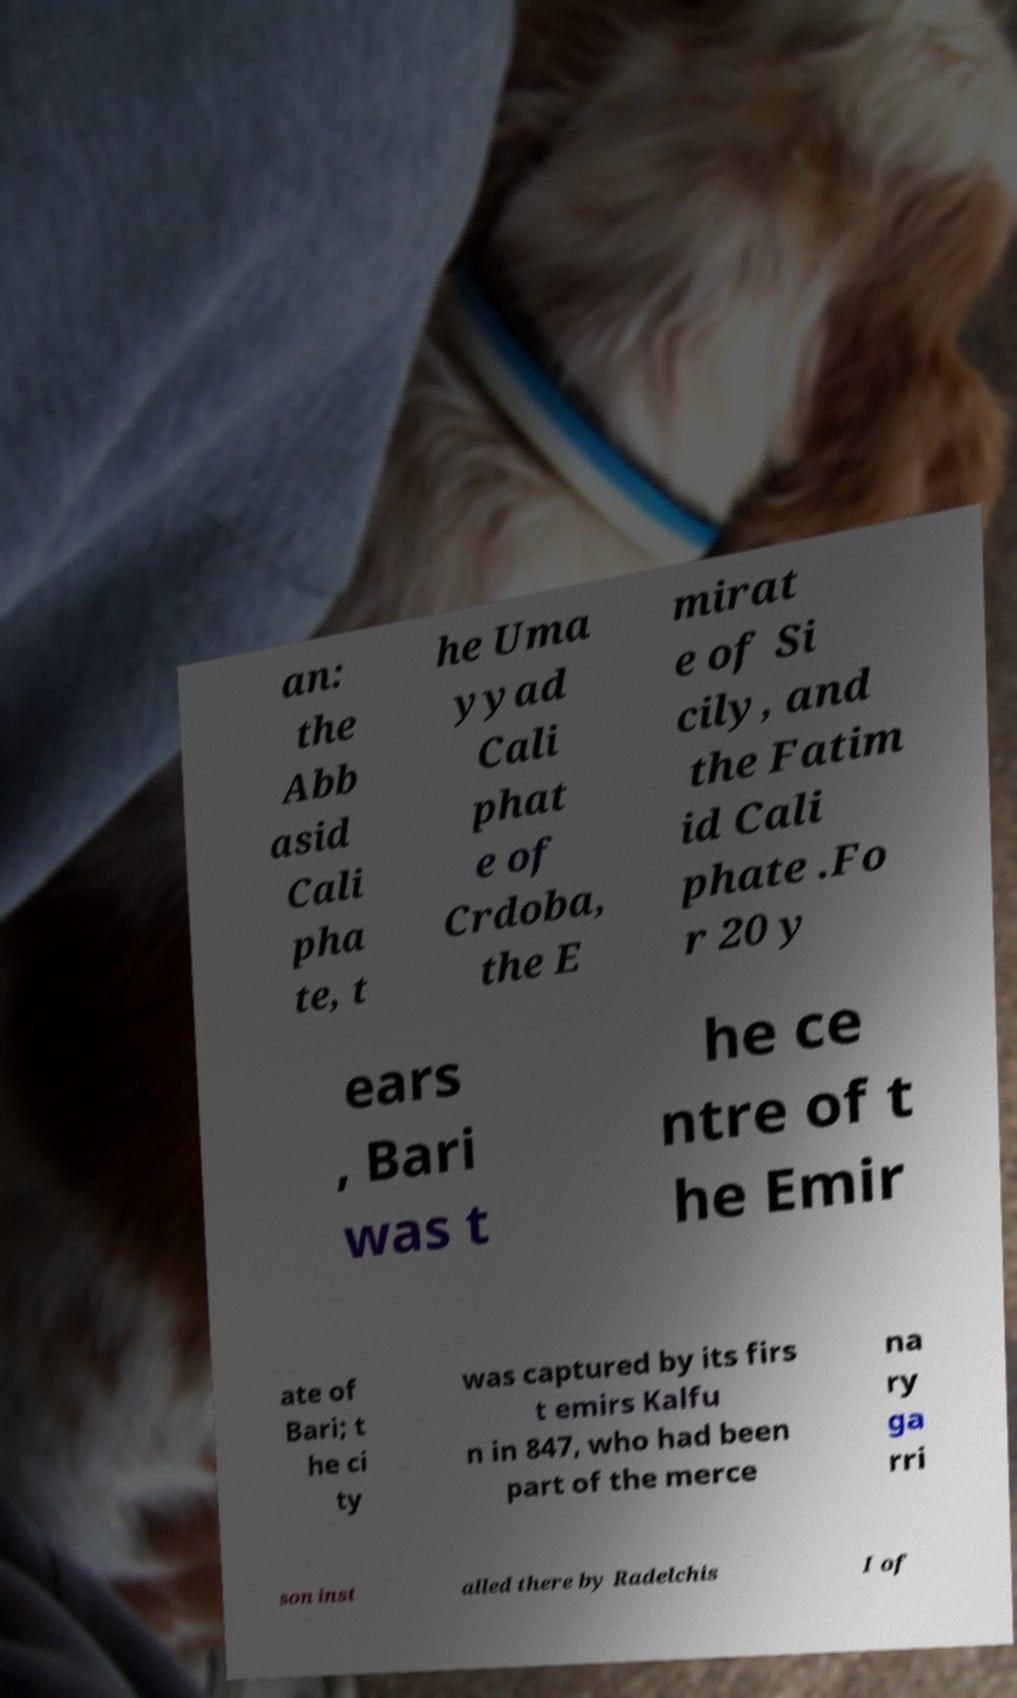Could you extract and type out the text from this image? an: the Abb asid Cali pha te, t he Uma yyad Cali phat e of Crdoba, the E mirat e of Si cily, and the Fatim id Cali phate .Fo r 20 y ears , Bari was t he ce ntre of t he Emir ate of Bari; t he ci ty was captured by its firs t emirs Kalfu n in 847, who had been part of the merce na ry ga rri son inst alled there by Radelchis I of 